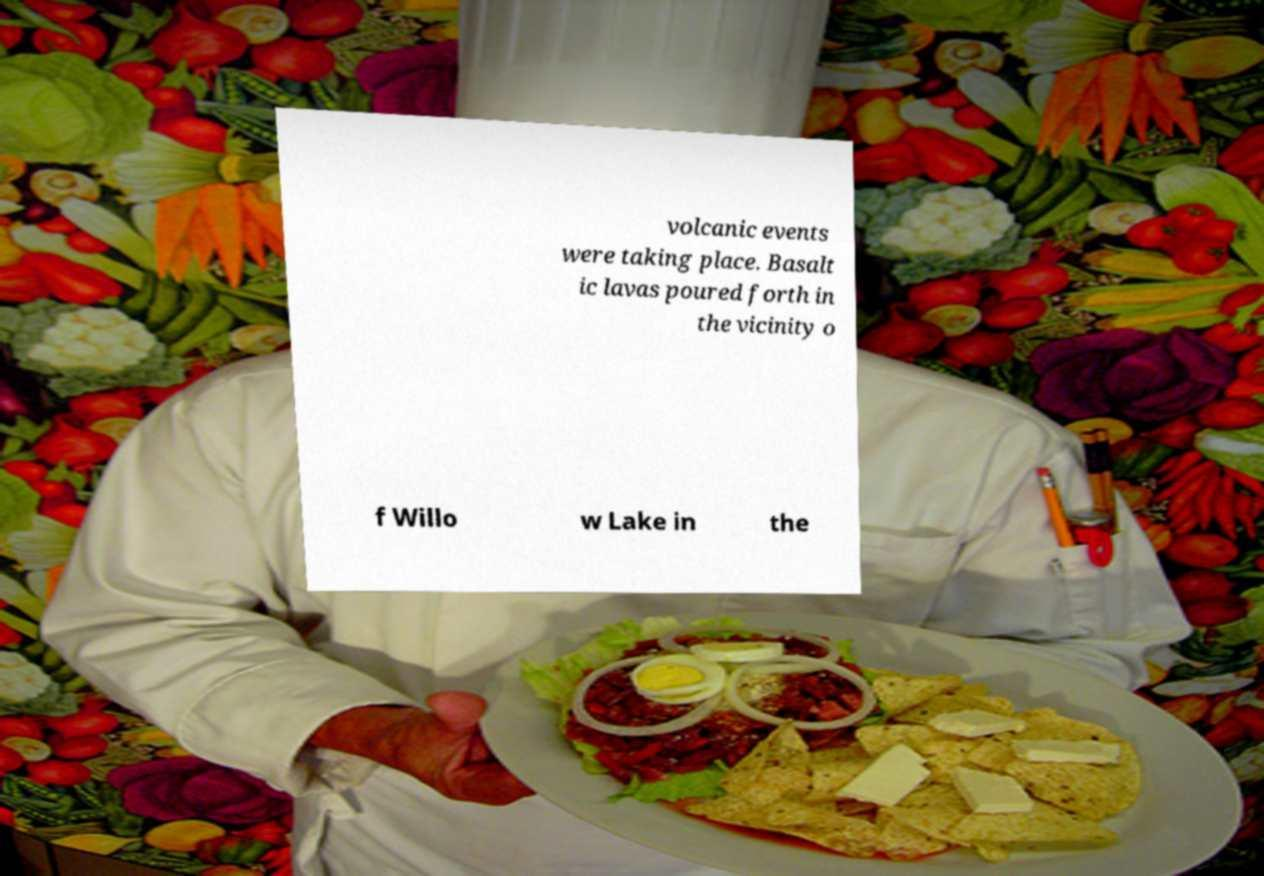Please identify and transcribe the text found in this image. volcanic events were taking place. Basalt ic lavas poured forth in the vicinity o f Willo w Lake in the 